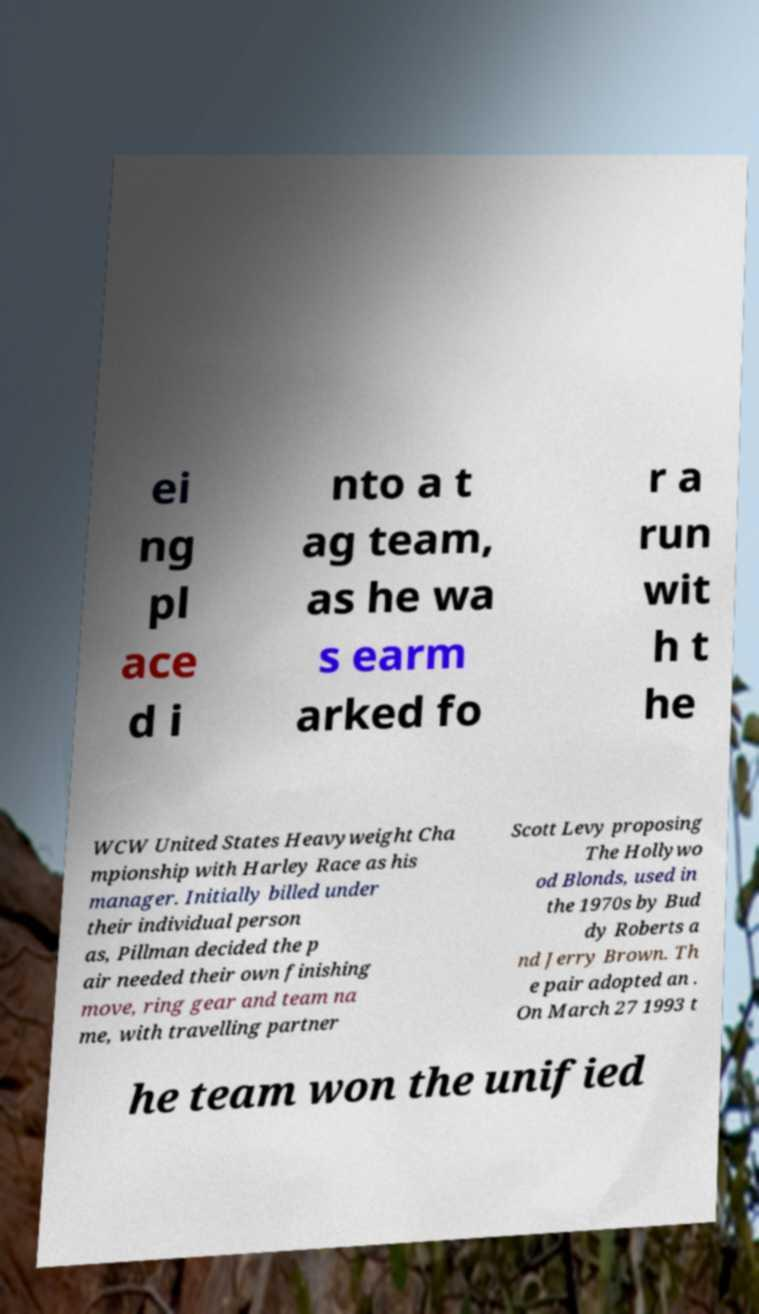Could you assist in decoding the text presented in this image and type it out clearly? ei ng pl ace d i nto a t ag team, as he wa s earm arked fo r a run wit h t he WCW United States Heavyweight Cha mpionship with Harley Race as his manager. Initially billed under their individual person as, Pillman decided the p air needed their own finishing move, ring gear and team na me, with travelling partner Scott Levy proposing The Hollywo od Blonds, used in the 1970s by Bud dy Roberts a nd Jerry Brown. Th e pair adopted an . On March 27 1993 t he team won the unified 